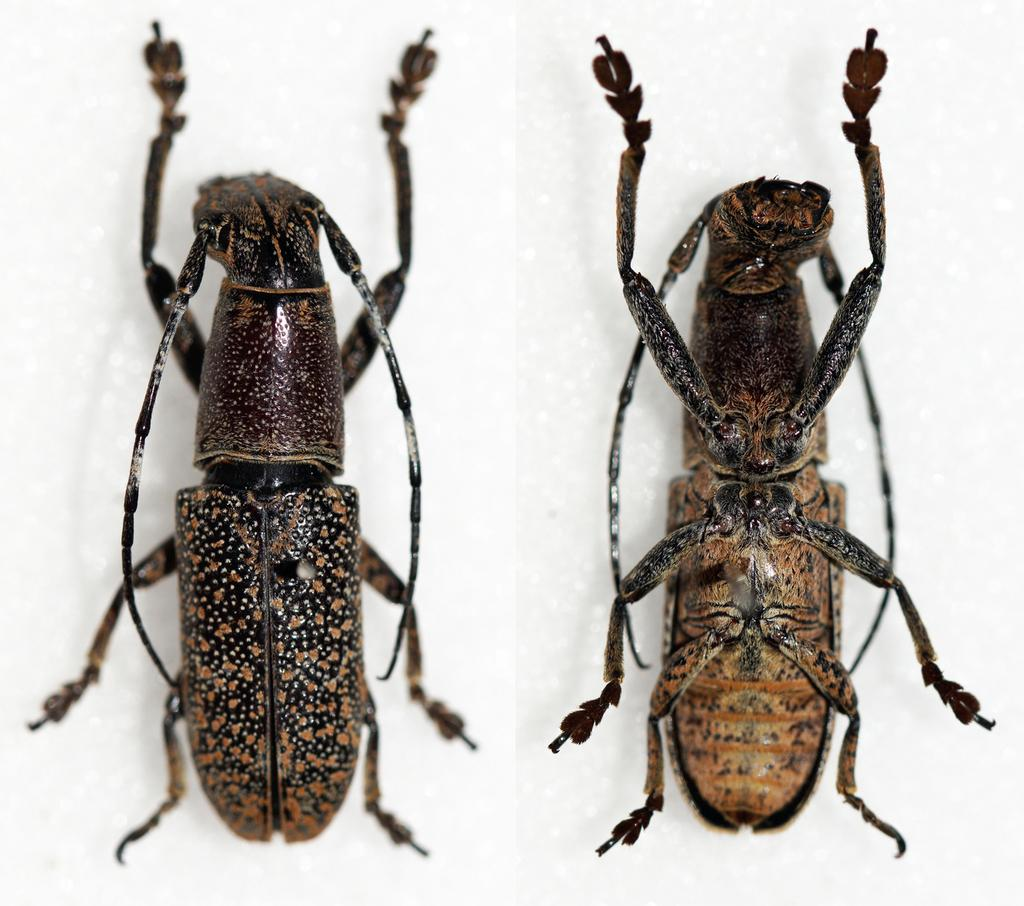How many insects are present in the image? There are two insects in the image. What can be seen in the background of the image? The background of the image is white. Is there a man holding a camera while taking a flight in the image? No, there is no man, camera, or flight depicted in the image; it only features two insects against a white background. 